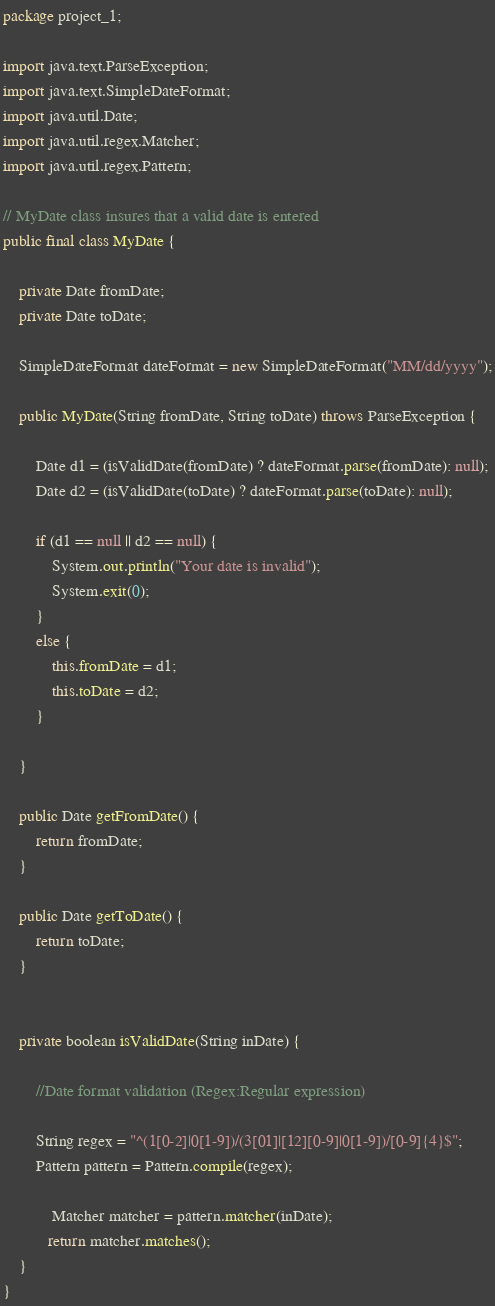<code> <loc_0><loc_0><loc_500><loc_500><_Java_>package project_1;

import java.text.ParseException;
import java.text.SimpleDateFormat;
import java.util.Date;
import java.util.regex.Matcher;
import java.util.regex.Pattern;

// MyDate class insures that a valid date is entered
public final class MyDate {
	
	private Date fromDate;
	private Date toDate;
	
	SimpleDateFormat dateFormat = new SimpleDateFormat("MM/dd/yyyy");
	
	public MyDate(String fromDate, String toDate) throws ParseException {
		
		Date d1 = (isValidDate(fromDate) ? dateFormat.parse(fromDate): null);
		Date d2 = (isValidDate(toDate) ? dateFormat.parse(toDate): null);
		
		if (d1 == null || d2 == null) {
			System.out.println("Your date is invalid");
			System.exit(0);
		}
		else {
			this.fromDate = d1;
			this.toDate = d2;
		}
		
	}

	public Date getFromDate() {
		return fromDate;
	}

	public Date getToDate() {
		return toDate;
	}
	
	
	private boolean isValidDate(String inDate) {
		
		//Date format validation (Regex:Regular expression)
		
		String regex = "^(1[0-2]|0[1-9])/(3[01]|[12][0-9]|0[1-9])/[0-9]{4}$";
		Pattern pattern = Pattern.compile(regex);
		
		    Matcher matcher = pattern.matcher(inDate);
		   return matcher.matches();
	}
}
</code> 